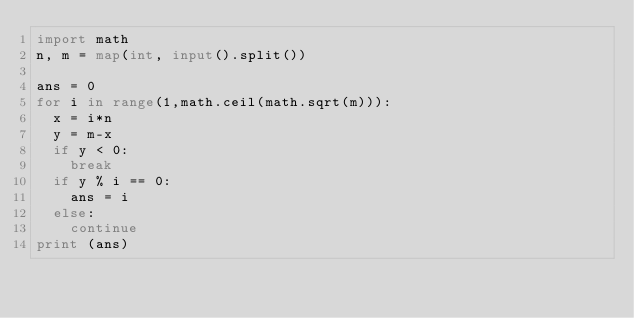<code> <loc_0><loc_0><loc_500><loc_500><_Python_>import math
n, m = map(int, input().split())
 
ans = 0
for i in range(1,math.ceil(math.sqrt(m))):
	x = i*n
	y = m-x
	if y < 0:
		break
	if y % i == 0:
		ans = i
	else:
		continue
print (ans)</code> 